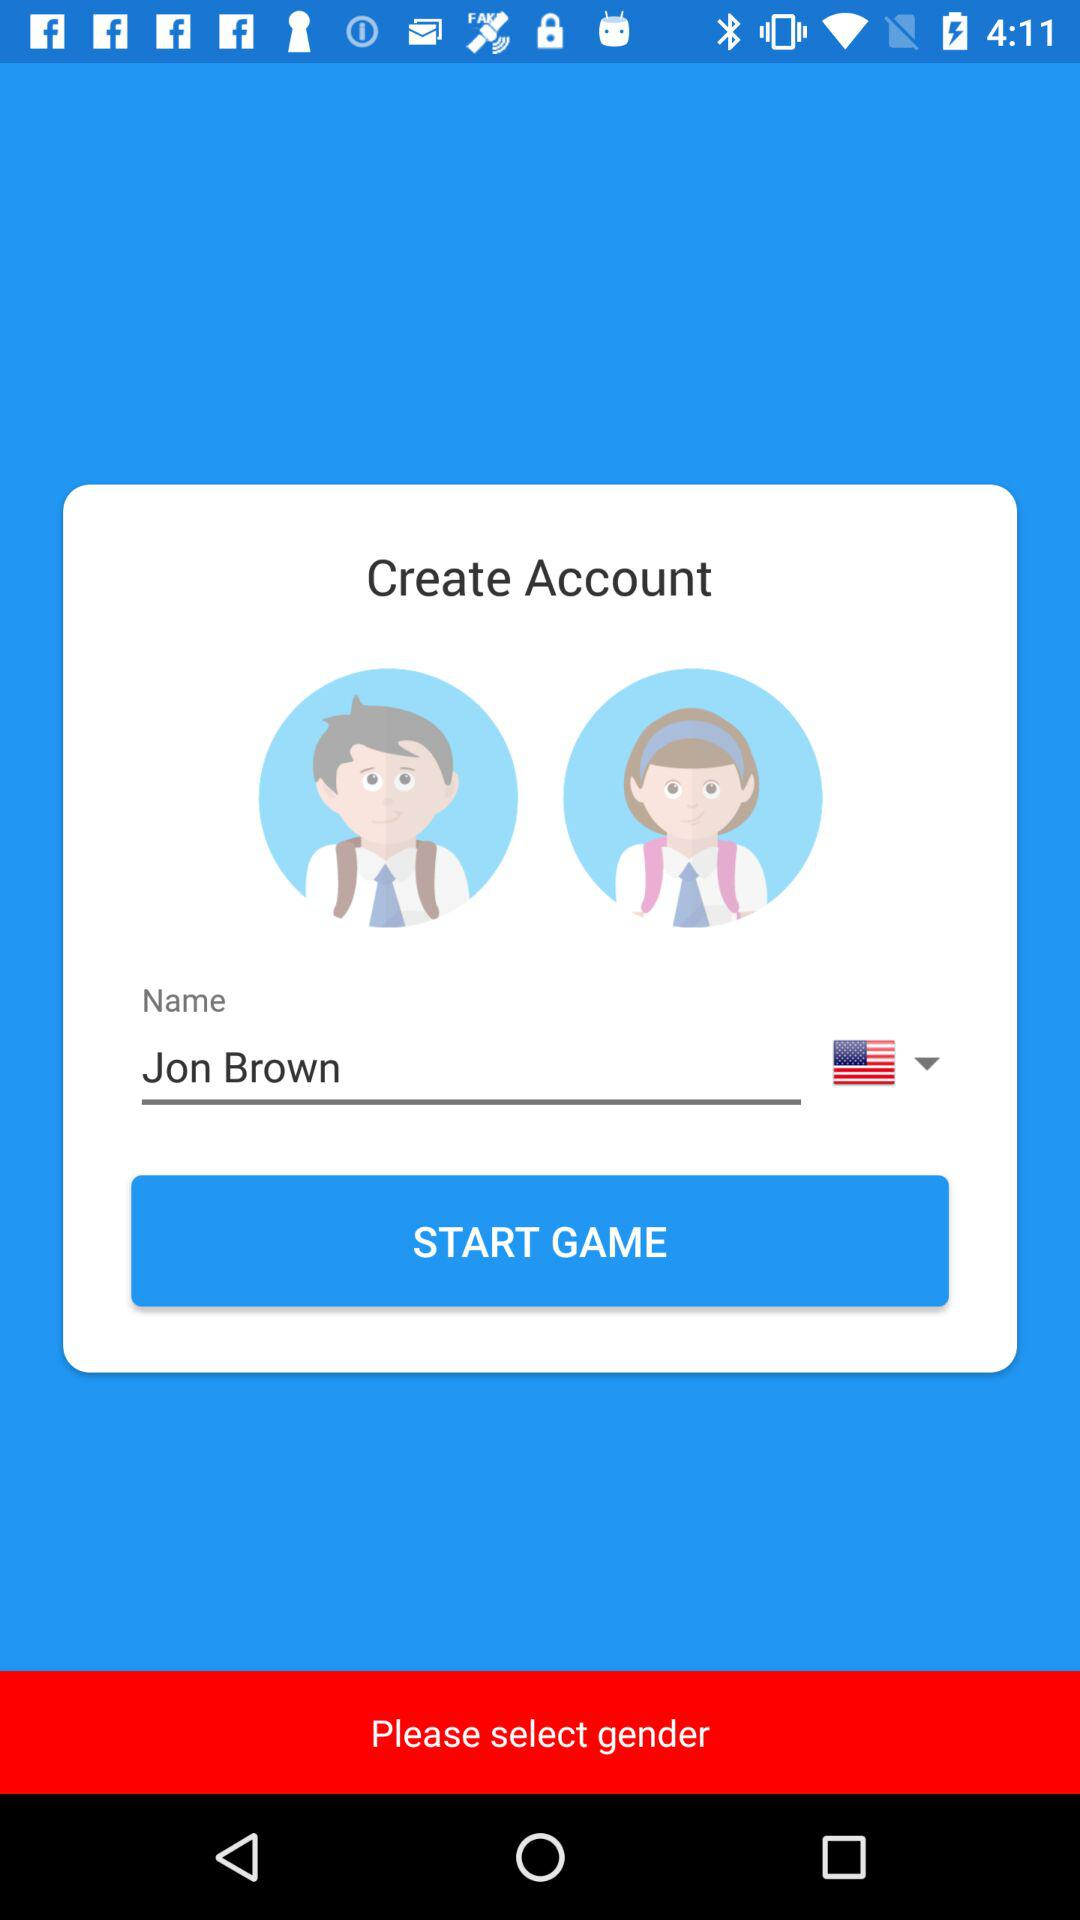What is the name of the user? The name of the user is Jon Brown. 